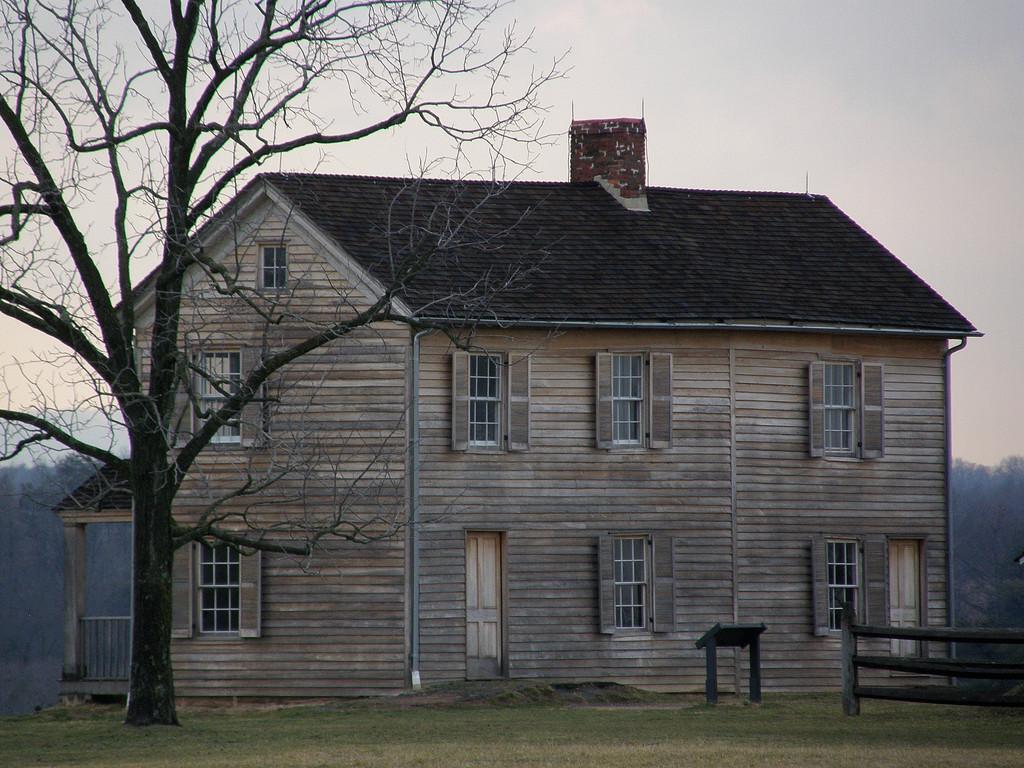How would you summarize this image in a sentence or two? In this image we can see the tree, wooden fence, grassland, wooden house and the sky in the background. 